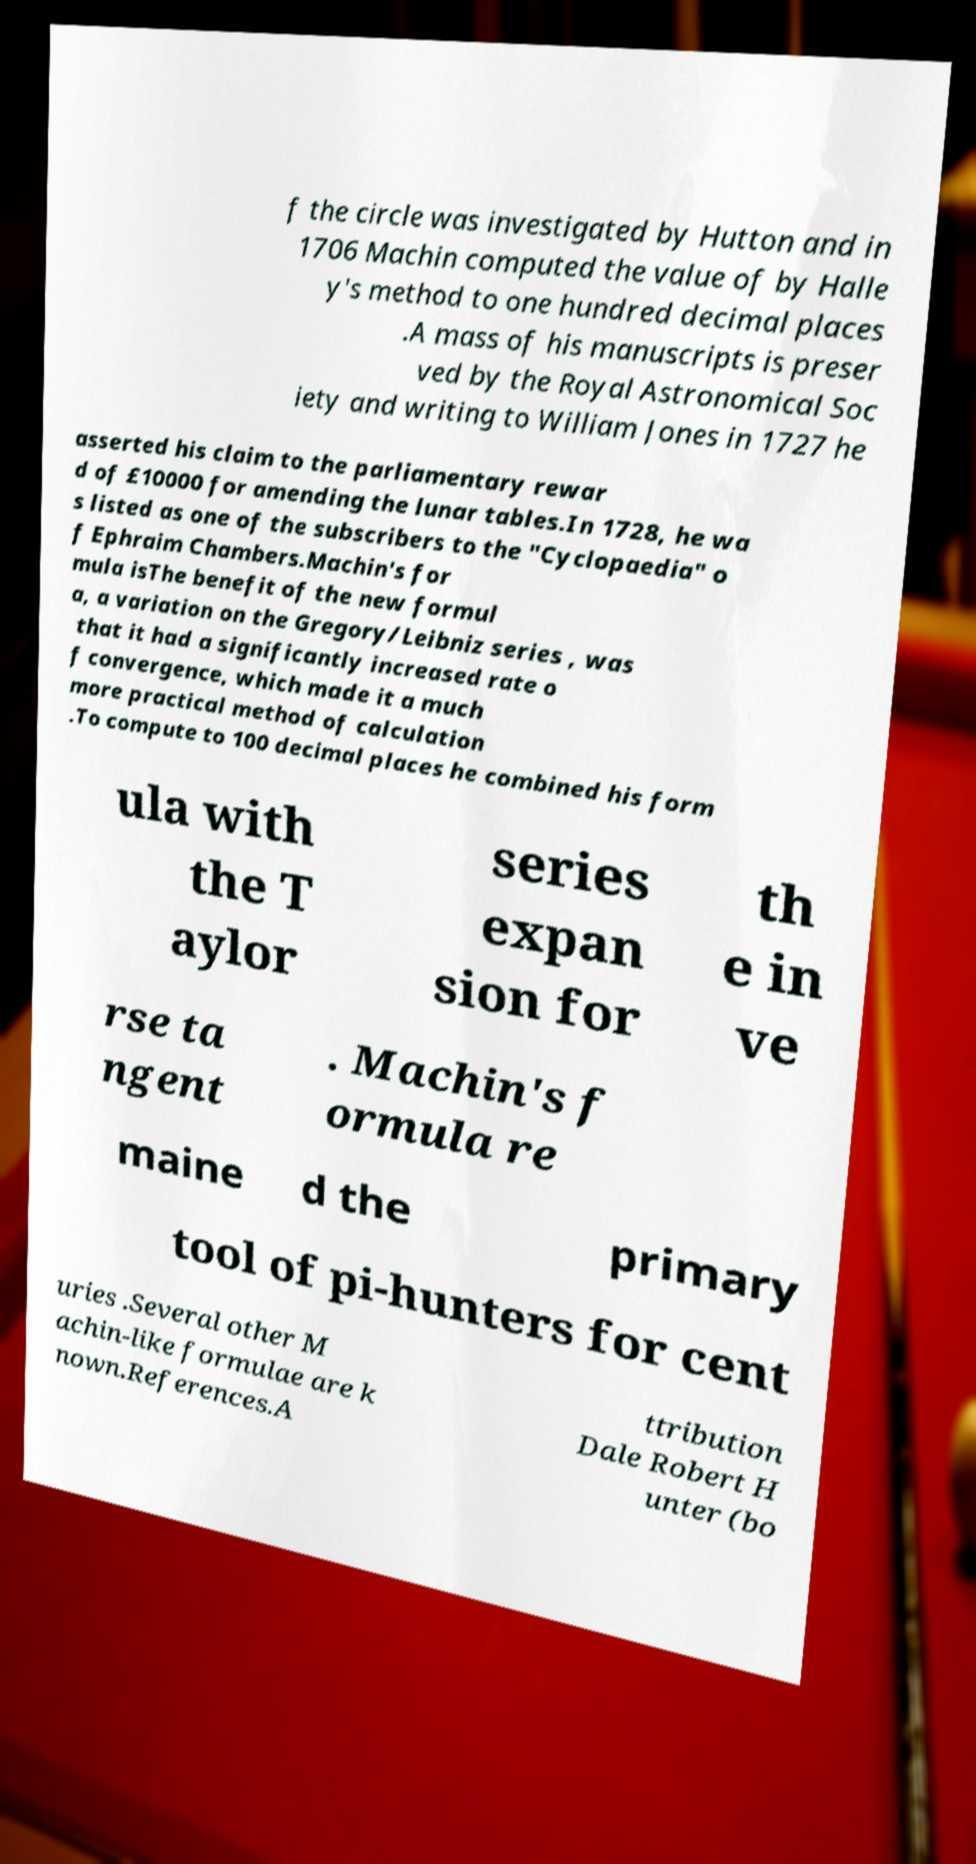Could you extract and type out the text from this image? f the circle was investigated by Hutton and in 1706 Machin computed the value of by Halle y's method to one hundred decimal places .A mass of his manuscripts is preser ved by the Royal Astronomical Soc iety and writing to William Jones in 1727 he asserted his claim to the parliamentary rewar d of £10000 for amending the lunar tables.In 1728, he wa s listed as one of the subscribers to the "Cyclopaedia" o f Ephraim Chambers.Machin's for mula isThe benefit of the new formul a, a variation on the Gregory/Leibniz series , was that it had a significantly increased rate o f convergence, which made it a much more practical method of calculation .To compute to 100 decimal places he combined his form ula with the T aylor series expan sion for th e in ve rse ta ngent . Machin's f ormula re maine d the primary tool of pi-hunters for cent uries .Several other M achin-like formulae are k nown.References.A ttribution Dale Robert H unter (bo 